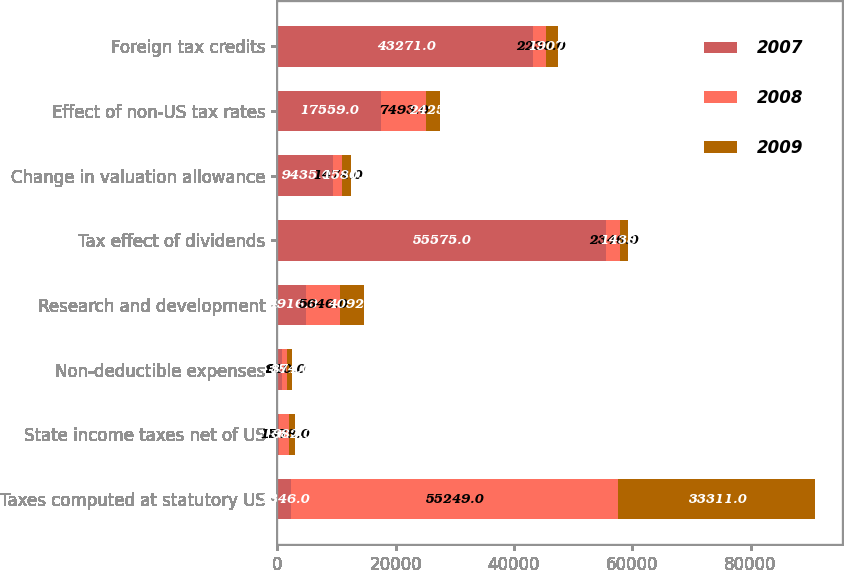Convert chart to OTSL. <chart><loc_0><loc_0><loc_500><loc_500><stacked_bar_chart><ecel><fcel>Taxes computed at statutory US<fcel>State income taxes net of US<fcel>Non-deductible expenses<fcel>Research and development<fcel>Tax effect of dividends<fcel>Change in valuation allowance<fcel>Effect of non-US tax rates<fcel>Foreign tax credits<nl><fcel>2007<fcel>2346<fcel>346<fcel>748<fcel>4916<fcel>55575<fcel>9435<fcel>17559<fcel>43271<nl><fcel>2008<fcel>55249<fcel>1578<fcel>910<fcel>5646<fcel>2346<fcel>1474<fcel>7493<fcel>2230<nl><fcel>2009<fcel>33311<fcel>982<fcel>874<fcel>4092<fcel>1438<fcel>1580<fcel>2425<fcel>1907<nl></chart> 